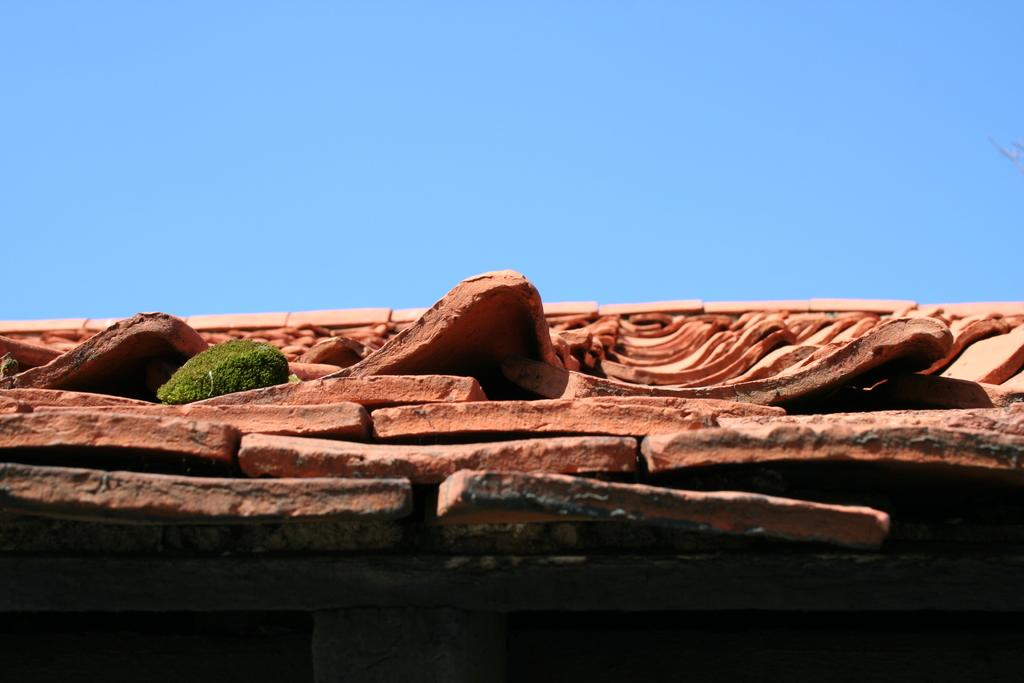What is present on top of the structure in the image? There is a roof in the image. What material is used for the roof in the image? There are bricks on the roof in the image. How many deer can be seen grazing on the roof in the image? There are no deer present in the image; the roof is made of bricks. 